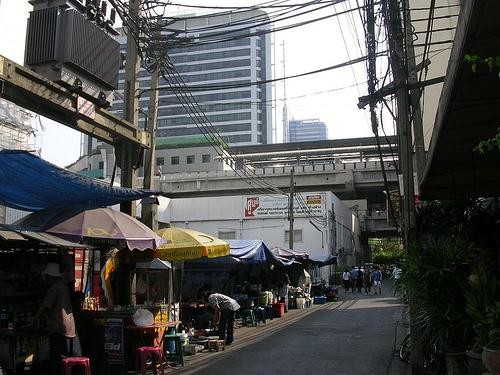Why are there tarps and umbrellas?

Choices:
A) construction
B) beach
C) raining
D) market market 